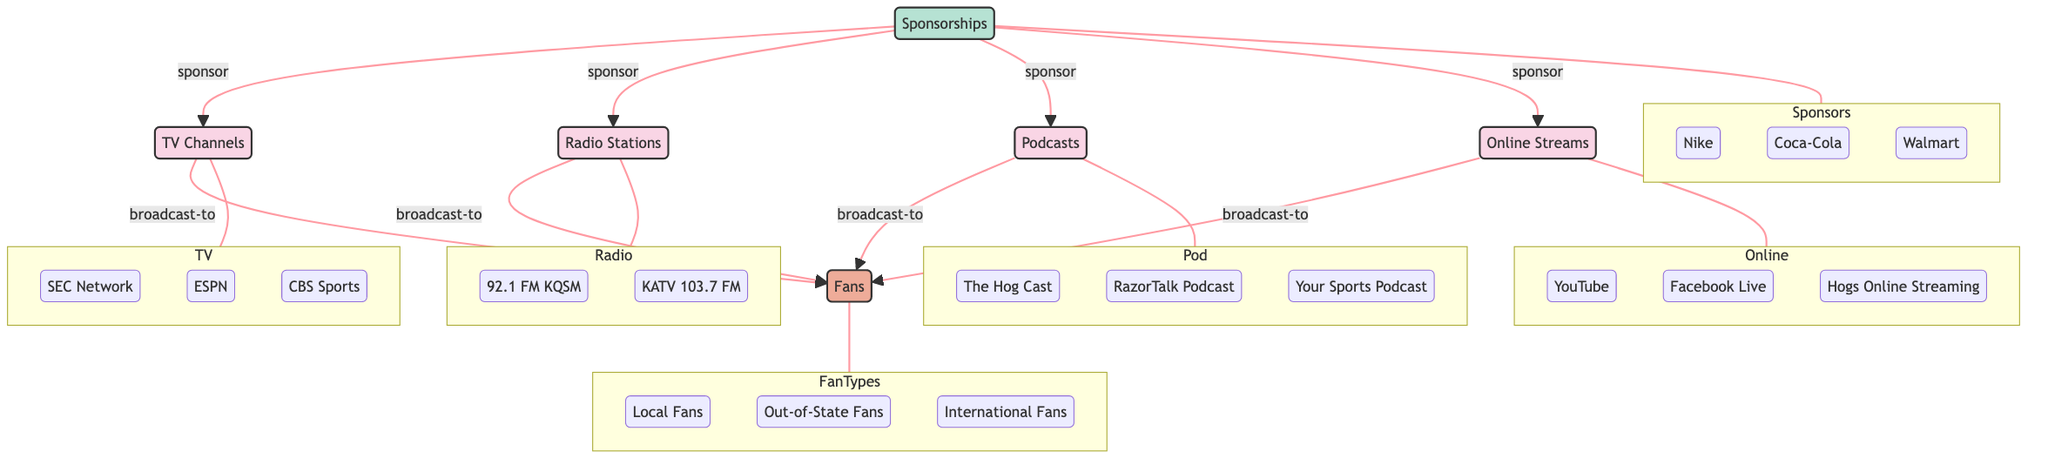What types of media outlets are in the diagram? The diagram includes four types of media outlets: TV Channels, Radio Stations, Podcasts, and Online Streams. Each category is a top-level node leading to specific channels or programs underneath.
Answer: TV Channels, Radio Stations, Podcasts, Online Streams How many sponsorships are involved in the broadcasting ecosystem? The diagram indicates there are three sponsors listed under the sponsorships node: Nike, Coca-Cola, and Walmart. This is determined by counting the children of the sponsorships node.
Answer: 3 Which TV channel is specifically mentioned for Razorbacks games? The diagram identifies three TV channels, including SEC Network, ESPN, and CBS Sports, but only one specific channel that is related to coverage, such as SEC Network, is commonly associated with Razorbacks games.
Answer: SEC Network What is the relationship between Online Streams and Fans? The online streams node is linked to the fans node by a "broadcast-to" relationship, which indicates that online streams are a medium through which fans receive Razorback game coverage.
Answer: broadcast-to How many types of fans are recognized in this diagram? The diagram categorizes fans into three distinct types: Local Fans, Out-of-State Fans, and International Fans. This total is derived from analyzing the children of the fans node.
Answer: 3 Which media outlet category connects all types of fans? Analyzing the branches of the diagram shows that all four media outlet categories (TV Channels, Radio Stations, Podcasts, Online Streams) connect to the fans node, indicating they all reach fans directly.
Answer: all four categories What sponsorship relationship exists with Online Streams? Online Streams is linked to the sponsorships node by a "sponsor" relationship, indicating that sponsors support or fund the online broadcasting venues for Razorbacks games.
Answer: sponsor Do radio stations also connect to sponsorships? Yes, the diagram shows that radio stations are connected to sponsorships by a "sponsor" relationship, implying that radio outlets like 92.1 FM (KQSM) and KATV 103.7 FM receive sponsorship.
Answer: Yes 